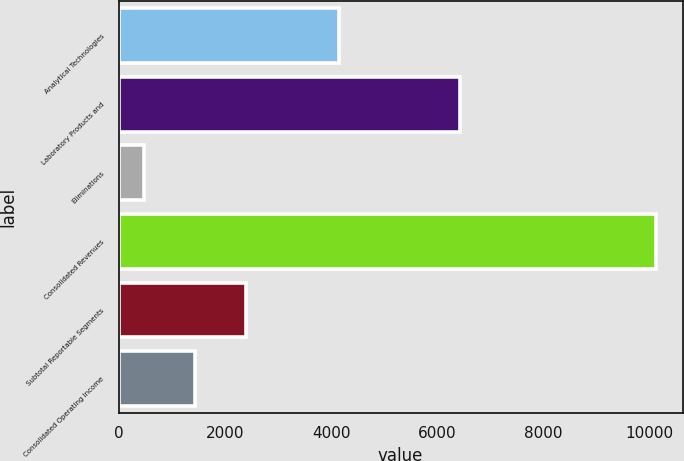Convert chart. <chart><loc_0><loc_0><loc_500><loc_500><bar_chart><fcel>Analytical Technologies<fcel>Laboratory Products and<fcel>Eliminations<fcel>Consolidated Revenues<fcel>Subtotal Reportable Segments<fcel>Consolidated Operating Income<nl><fcel>4153.9<fcel>6426.6<fcel>470.8<fcel>10109.7<fcel>2398.58<fcel>1434.69<nl></chart> 